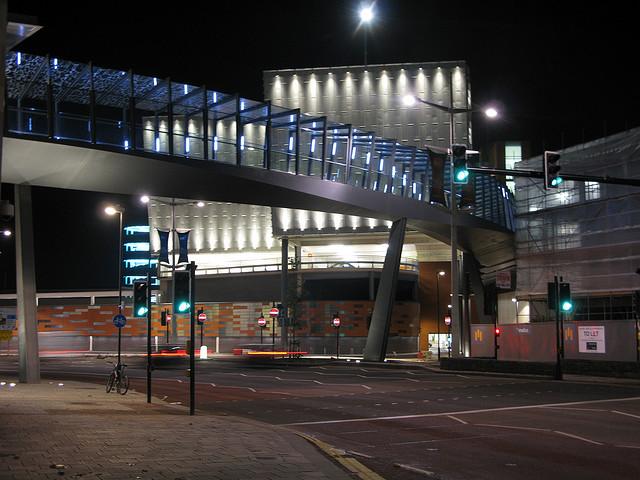How many lights do you see?
Quick response, please. 45. Is it daytime or nighttime?
Give a very brief answer. Nighttime. What color is the traffic light?
Be succinct. Green. 